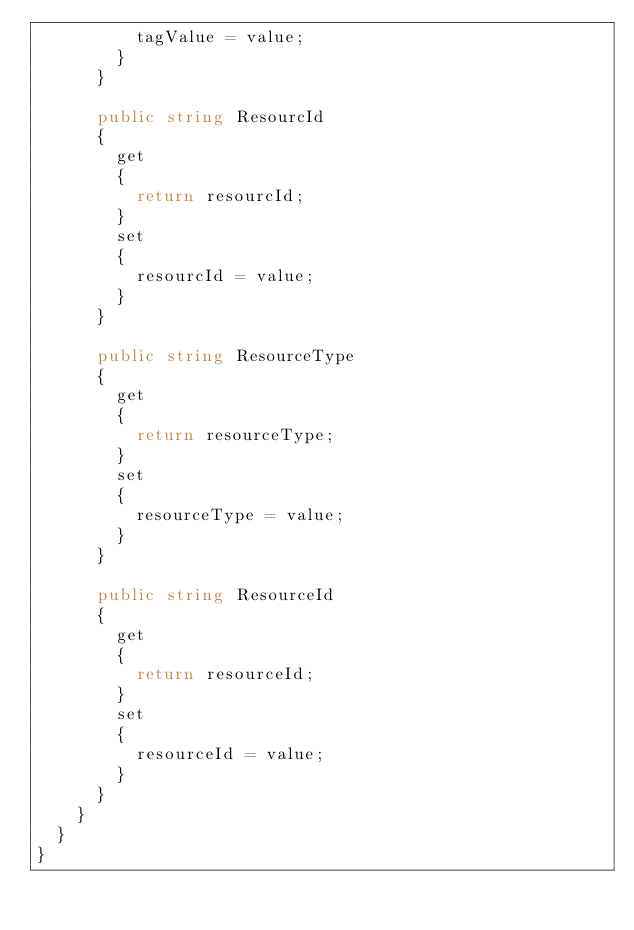<code> <loc_0><loc_0><loc_500><loc_500><_C#_>					tagValue = value;
				}
			}

			public string ResourcId
			{
				get
				{
					return resourcId;
				}
				set	
				{
					resourcId = value;
				}
			}

			public string ResourceType
			{
				get
				{
					return resourceType;
				}
				set	
				{
					resourceType = value;
				}
			}

			public string ResourceId
			{
				get
				{
					return resourceId;
				}
				set	
				{
					resourceId = value;
				}
			}
		}
	}
}
</code> 